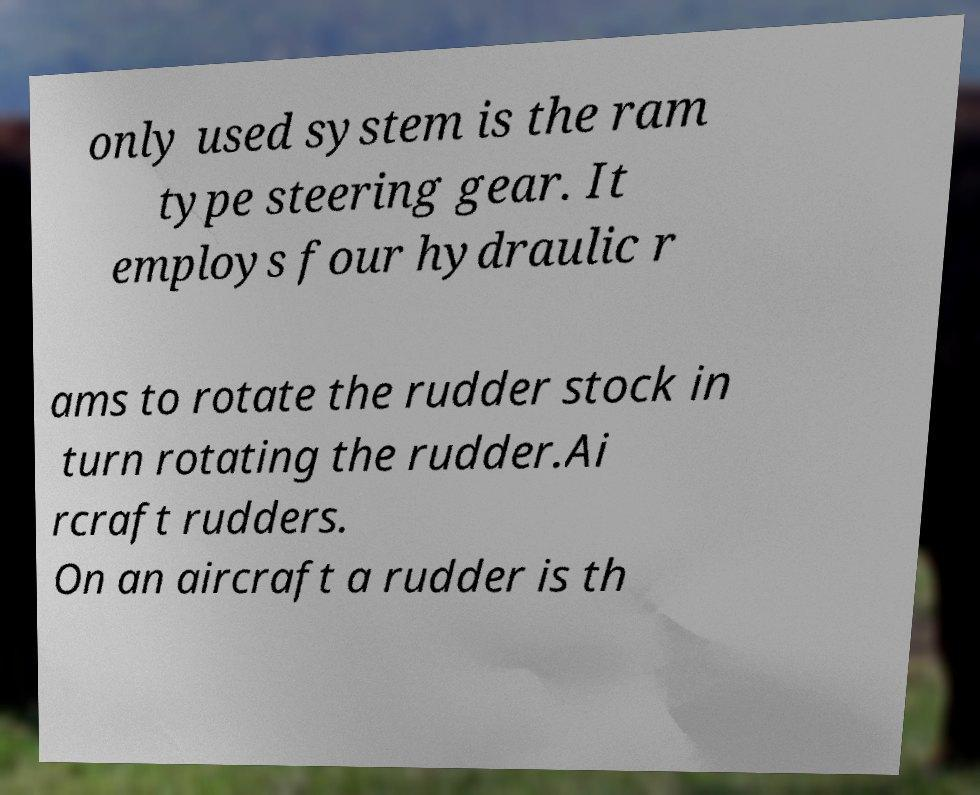Can you read and provide the text displayed in the image?This photo seems to have some interesting text. Can you extract and type it out for me? only used system is the ram type steering gear. It employs four hydraulic r ams to rotate the rudder stock in turn rotating the rudder.Ai rcraft rudders. On an aircraft a rudder is th 